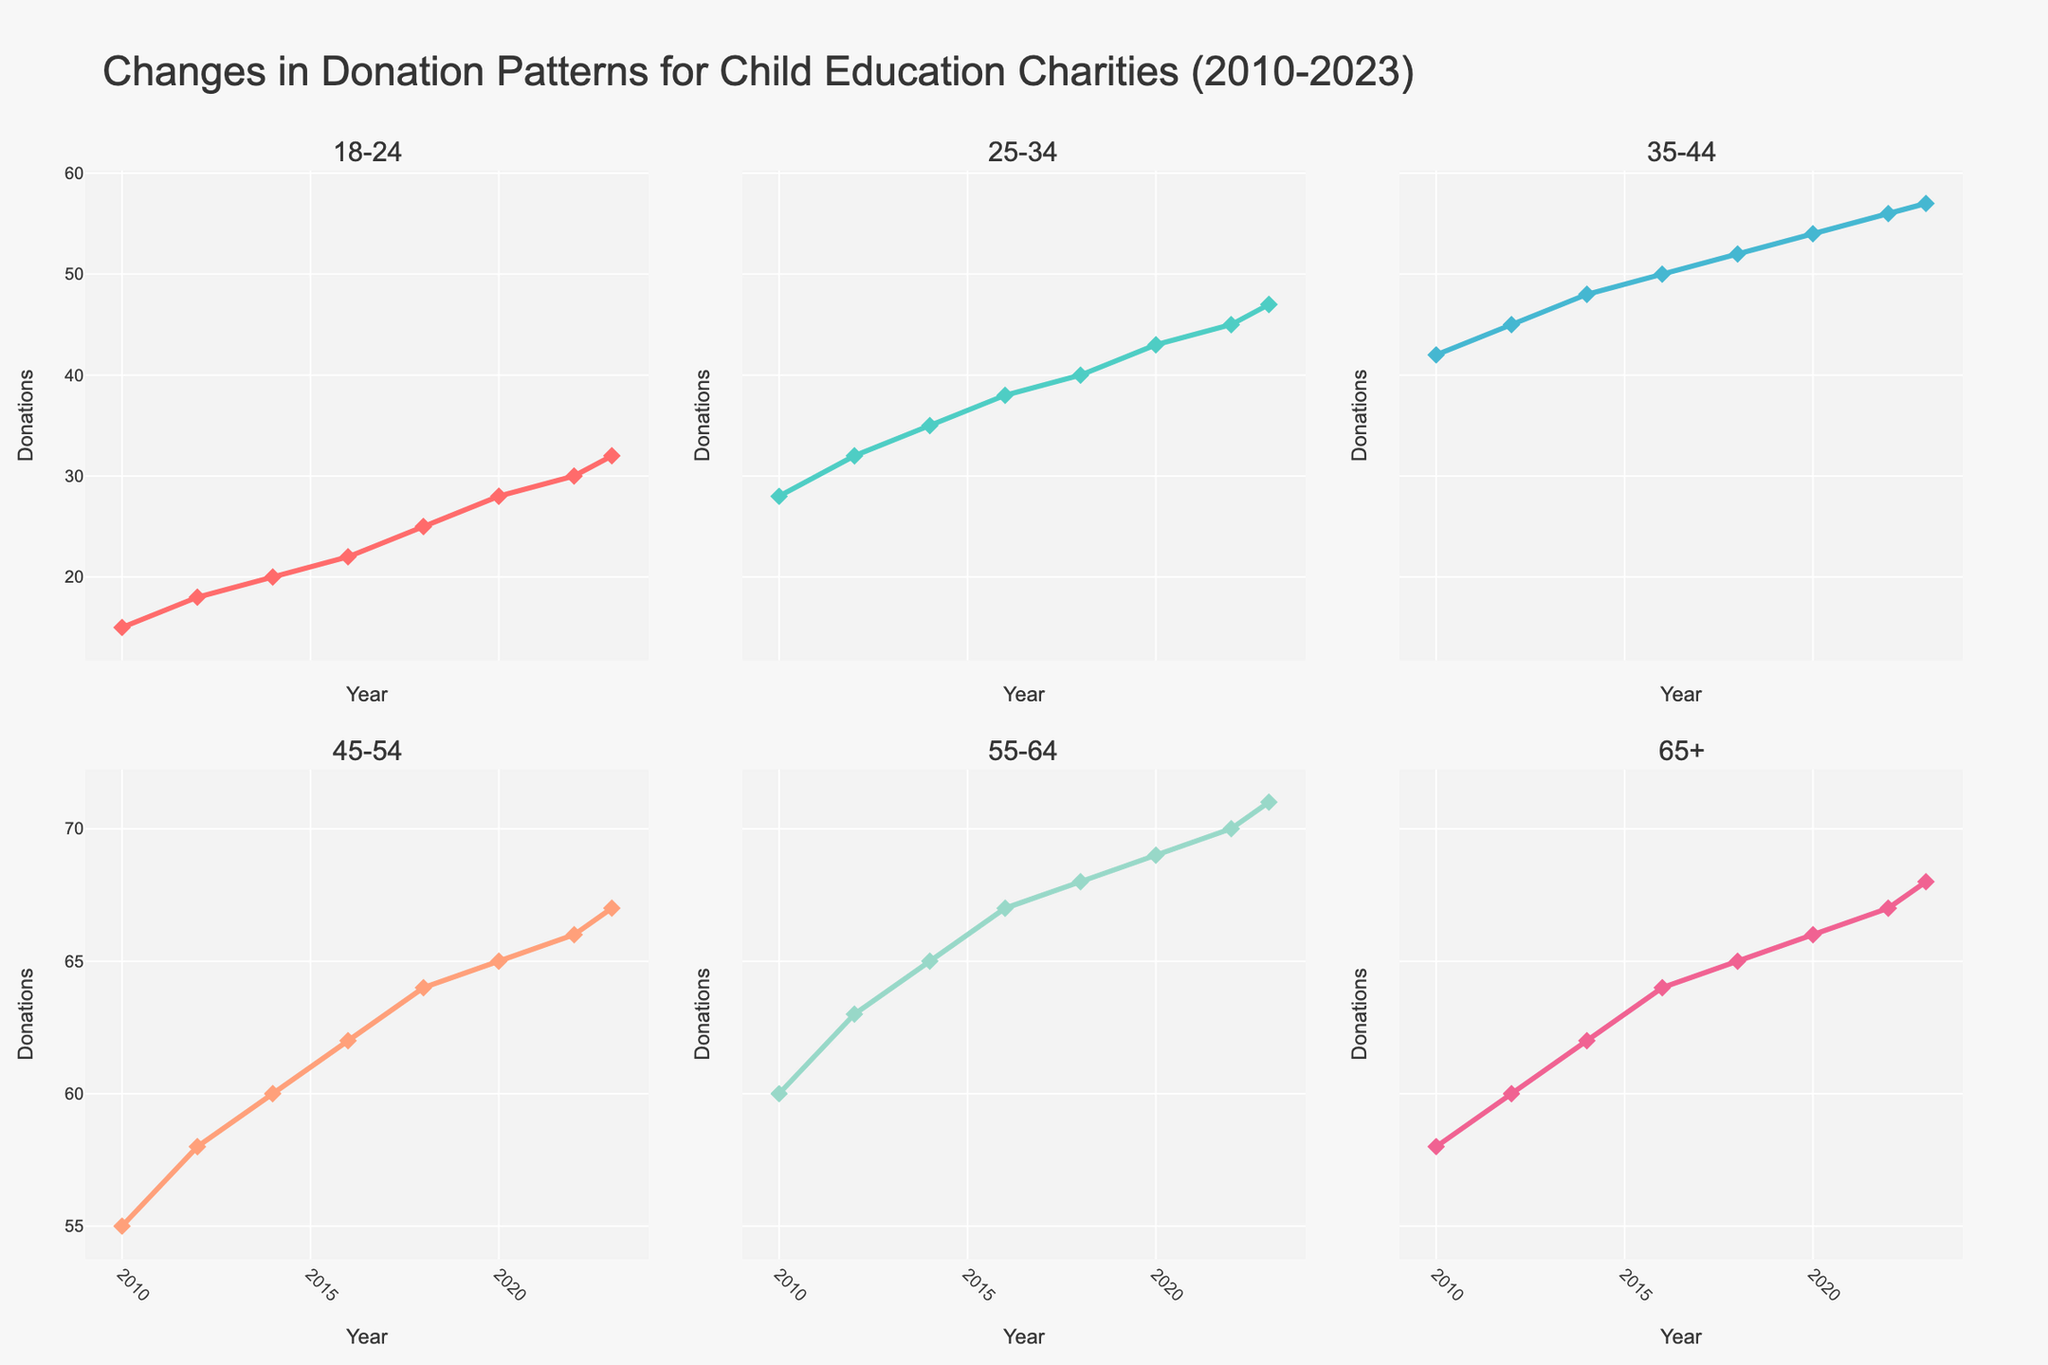Which age group shows the highest increase in donations from 2010 to 2023? To determine the highest increase, calculate the difference in donations between 2023 and 2010 for each age group. The differences are: 18-24 (32-15=17), 25-34 (47-28=19), 35-44 (57-42=15), 45-54 (67-55=12), 55-64 (71-60=11), and 65+ (68-58=10). Hence, 25-34 age group shows the highest increase.
Answer: 25-34 What is the total donation value for the 45-54 age group across the years? Sum up the donation values for the 45-54 age group: 55 (2010) + 58 (2012) + 60 (2014) + 62 (2016) + 64 (2018) + 65 (2020) + 66 (2022) + 67 (2023). The total is 497.
Answer: 497 Which age group had the least donations in 2010? Look at the donation values for each age group in 2010: 18-24 (15), 25-34 (28), 35-44 (42), 45-54 (55), 55-64 (60), and 65+ (58). The 18-24 age group had the least donations in 2010.
Answer: 18-24 How do the donation patterns of the 18-24 age group compare between 2012 and 2018? Compare the donation values for the 18-24 age group in 2012 (18) and 2018 (25). The donations increased by 7 units from 18 to 25.
Answer: Increased by 7 Which age group had the highest donation amount in 2022? Investigate the donation values in 2022: 18-24 (30), 25-34 (45), 35-44 (56), 45-54 (66), 55-64 (70), and 65+ (67). The 55-64 age group had the highest donation amount in 2022.
Answer: 55-64 Is there any age group where the donation values stayed consistent across any of the years? Examine the donation trends for each age group. There are no years where any age group shows no change in donations from one year to the next; each group shows an increase over time.
Answer: No What is the average donation amount for the 35-44 age group across all the years? Average the values: (42+45+48+50+52+54+56+57)/8 = 404/8 = 50.5. The average donation amount for the 35-44 age group is 50.5.
Answer: 50.5 Which two age groups have the closest donation amounts in the year 2020? Compare the 2020 values: 18-24 (28), 25-34 (43), 35-44 (54), 45-54 (65), 55-64 (69), and 65+ (66). The 55-64 and 65+ age groups have the closest donation amounts with a difference of 3 units.
Answer: 55-64 and 65+ 